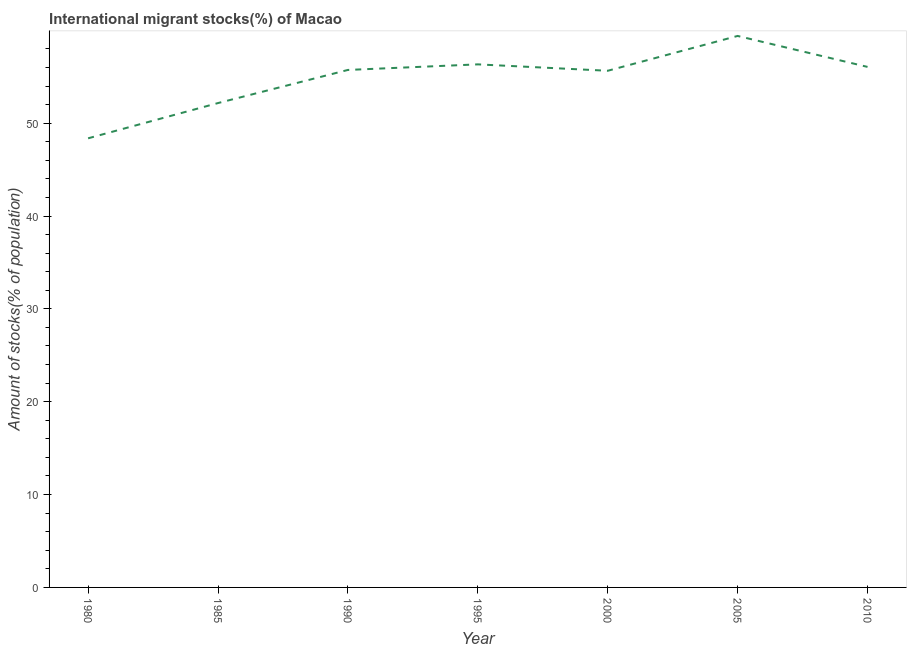What is the number of international migrant stocks in 2010?
Make the answer very short. 56.06. Across all years, what is the maximum number of international migrant stocks?
Your response must be concise. 59.39. Across all years, what is the minimum number of international migrant stocks?
Your answer should be compact. 48.37. In which year was the number of international migrant stocks maximum?
Your answer should be very brief. 2005. What is the sum of the number of international migrant stocks?
Offer a terse response. 383.68. What is the difference between the number of international migrant stocks in 2000 and 2010?
Give a very brief answer. -0.42. What is the average number of international migrant stocks per year?
Offer a very short reply. 54.81. What is the median number of international migrant stocks?
Provide a short and direct response. 55.73. In how many years, is the number of international migrant stocks greater than 30 %?
Your answer should be very brief. 7. What is the ratio of the number of international migrant stocks in 1995 to that in 2010?
Make the answer very short. 1. Is the number of international migrant stocks in 1990 less than that in 2000?
Keep it short and to the point. No. What is the difference between the highest and the second highest number of international migrant stocks?
Your response must be concise. 3.06. What is the difference between the highest and the lowest number of international migrant stocks?
Keep it short and to the point. 11.02. Does the number of international migrant stocks monotonically increase over the years?
Ensure brevity in your answer.  No. What is the title of the graph?
Keep it short and to the point. International migrant stocks(%) of Macao. What is the label or title of the Y-axis?
Provide a succinct answer. Amount of stocks(% of population). What is the Amount of stocks(% of population) of 1980?
Your response must be concise. 48.37. What is the Amount of stocks(% of population) in 1985?
Offer a very short reply. 52.16. What is the Amount of stocks(% of population) of 1990?
Your answer should be very brief. 55.73. What is the Amount of stocks(% of population) of 1995?
Ensure brevity in your answer.  56.33. What is the Amount of stocks(% of population) in 2000?
Offer a very short reply. 55.64. What is the Amount of stocks(% of population) of 2005?
Your answer should be compact. 59.39. What is the Amount of stocks(% of population) in 2010?
Offer a terse response. 56.06. What is the difference between the Amount of stocks(% of population) in 1980 and 1985?
Your response must be concise. -3.8. What is the difference between the Amount of stocks(% of population) in 1980 and 1990?
Offer a very short reply. -7.36. What is the difference between the Amount of stocks(% of population) in 1980 and 1995?
Make the answer very short. -7.96. What is the difference between the Amount of stocks(% of population) in 1980 and 2000?
Your response must be concise. -7.27. What is the difference between the Amount of stocks(% of population) in 1980 and 2005?
Your response must be concise. -11.02. What is the difference between the Amount of stocks(% of population) in 1980 and 2010?
Make the answer very short. -7.69. What is the difference between the Amount of stocks(% of population) in 1985 and 1990?
Offer a terse response. -3.57. What is the difference between the Amount of stocks(% of population) in 1985 and 1995?
Your answer should be compact. -4.17. What is the difference between the Amount of stocks(% of population) in 1985 and 2000?
Give a very brief answer. -3.48. What is the difference between the Amount of stocks(% of population) in 1985 and 2005?
Your answer should be compact. -7.23. What is the difference between the Amount of stocks(% of population) in 1985 and 2010?
Your answer should be compact. -3.89. What is the difference between the Amount of stocks(% of population) in 1990 and 1995?
Your response must be concise. -0.6. What is the difference between the Amount of stocks(% of population) in 1990 and 2000?
Give a very brief answer. 0.09. What is the difference between the Amount of stocks(% of population) in 1990 and 2005?
Offer a very short reply. -3.66. What is the difference between the Amount of stocks(% of population) in 1990 and 2010?
Provide a succinct answer. -0.33. What is the difference between the Amount of stocks(% of population) in 1995 and 2000?
Your answer should be compact. 0.69. What is the difference between the Amount of stocks(% of population) in 1995 and 2005?
Your answer should be compact. -3.06. What is the difference between the Amount of stocks(% of population) in 1995 and 2010?
Offer a very short reply. 0.27. What is the difference between the Amount of stocks(% of population) in 2000 and 2005?
Offer a very short reply. -3.75. What is the difference between the Amount of stocks(% of population) in 2000 and 2010?
Provide a succinct answer. -0.42. What is the difference between the Amount of stocks(% of population) in 2005 and 2010?
Make the answer very short. 3.33. What is the ratio of the Amount of stocks(% of population) in 1980 to that in 1985?
Your response must be concise. 0.93. What is the ratio of the Amount of stocks(% of population) in 1980 to that in 1990?
Your answer should be very brief. 0.87. What is the ratio of the Amount of stocks(% of population) in 1980 to that in 1995?
Offer a very short reply. 0.86. What is the ratio of the Amount of stocks(% of population) in 1980 to that in 2000?
Provide a succinct answer. 0.87. What is the ratio of the Amount of stocks(% of population) in 1980 to that in 2005?
Provide a short and direct response. 0.81. What is the ratio of the Amount of stocks(% of population) in 1980 to that in 2010?
Make the answer very short. 0.86. What is the ratio of the Amount of stocks(% of population) in 1985 to that in 1990?
Your response must be concise. 0.94. What is the ratio of the Amount of stocks(% of population) in 1985 to that in 1995?
Your answer should be compact. 0.93. What is the ratio of the Amount of stocks(% of population) in 1985 to that in 2000?
Offer a very short reply. 0.94. What is the ratio of the Amount of stocks(% of population) in 1985 to that in 2005?
Offer a terse response. 0.88. What is the ratio of the Amount of stocks(% of population) in 1985 to that in 2010?
Make the answer very short. 0.93. What is the ratio of the Amount of stocks(% of population) in 1990 to that in 1995?
Your response must be concise. 0.99. What is the ratio of the Amount of stocks(% of population) in 1990 to that in 2000?
Your answer should be very brief. 1. What is the ratio of the Amount of stocks(% of population) in 1990 to that in 2005?
Your answer should be compact. 0.94. What is the ratio of the Amount of stocks(% of population) in 1995 to that in 2005?
Your answer should be very brief. 0.95. What is the ratio of the Amount of stocks(% of population) in 1995 to that in 2010?
Your answer should be compact. 1. What is the ratio of the Amount of stocks(% of population) in 2000 to that in 2005?
Give a very brief answer. 0.94. What is the ratio of the Amount of stocks(% of population) in 2000 to that in 2010?
Ensure brevity in your answer.  0.99. What is the ratio of the Amount of stocks(% of population) in 2005 to that in 2010?
Offer a very short reply. 1.06. 